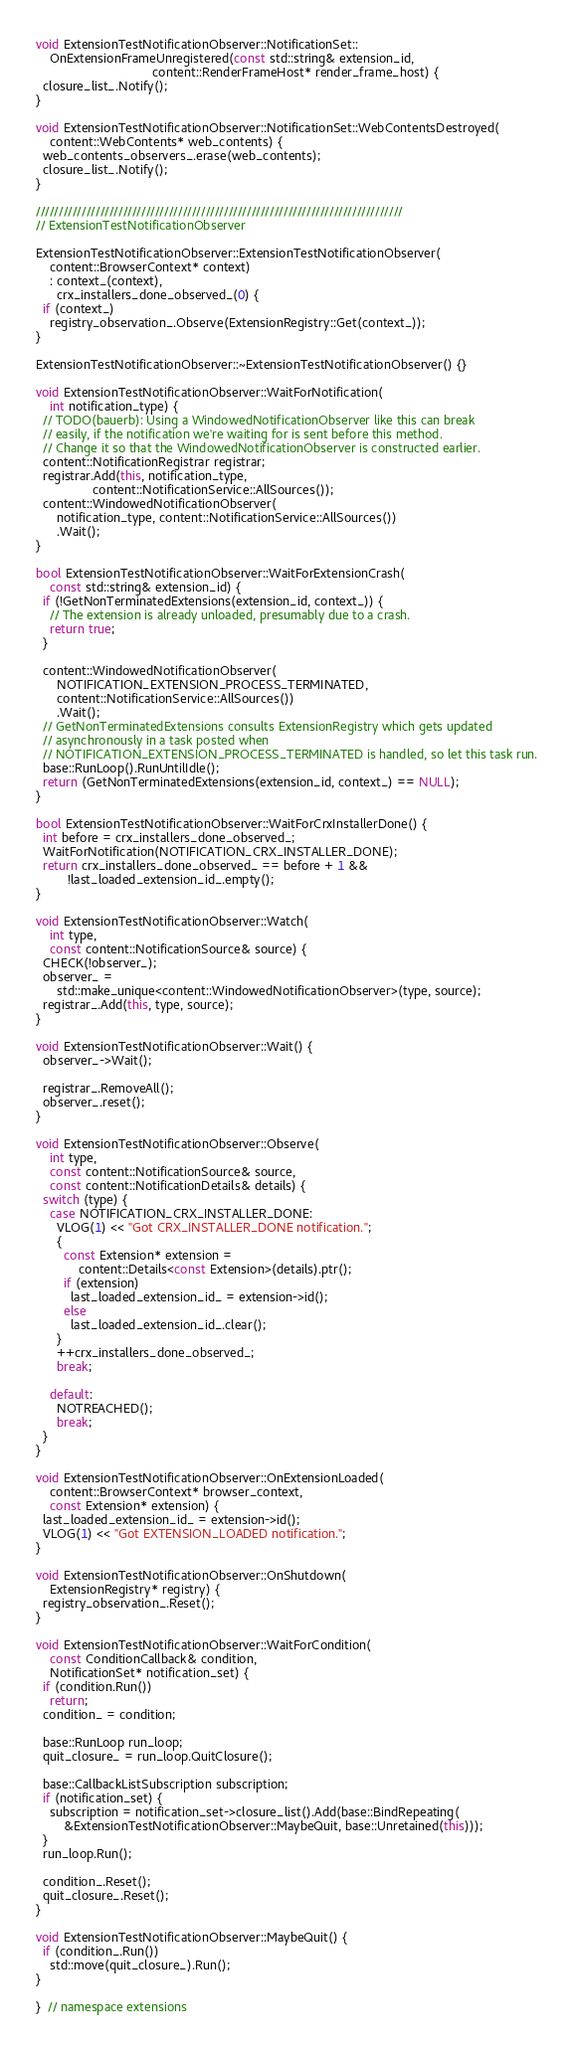<code> <loc_0><loc_0><loc_500><loc_500><_C++_>void ExtensionTestNotificationObserver::NotificationSet::
    OnExtensionFrameUnregistered(const std::string& extension_id,
                                 content::RenderFrameHost* render_frame_host) {
  closure_list_.Notify();
}

void ExtensionTestNotificationObserver::NotificationSet::WebContentsDestroyed(
    content::WebContents* web_contents) {
  web_contents_observers_.erase(web_contents);
  closure_list_.Notify();
}

////////////////////////////////////////////////////////////////////////////////
// ExtensionTestNotificationObserver

ExtensionTestNotificationObserver::ExtensionTestNotificationObserver(
    content::BrowserContext* context)
    : context_(context),
      crx_installers_done_observed_(0) {
  if (context_)
    registry_observation_.Observe(ExtensionRegistry::Get(context_));
}

ExtensionTestNotificationObserver::~ExtensionTestNotificationObserver() {}

void ExtensionTestNotificationObserver::WaitForNotification(
    int notification_type) {
  // TODO(bauerb): Using a WindowedNotificationObserver like this can break
  // easily, if the notification we're waiting for is sent before this method.
  // Change it so that the WindowedNotificationObserver is constructed earlier.
  content::NotificationRegistrar registrar;
  registrar.Add(this, notification_type,
                content::NotificationService::AllSources());
  content::WindowedNotificationObserver(
      notification_type, content::NotificationService::AllSources())
      .Wait();
}

bool ExtensionTestNotificationObserver::WaitForExtensionCrash(
    const std::string& extension_id) {
  if (!GetNonTerminatedExtensions(extension_id, context_)) {
    // The extension is already unloaded, presumably due to a crash.
    return true;
  }

  content::WindowedNotificationObserver(
      NOTIFICATION_EXTENSION_PROCESS_TERMINATED,
      content::NotificationService::AllSources())
      .Wait();
  // GetNonTerminatedExtensions consults ExtensionRegistry which gets updated
  // asynchronously in a task posted when
  // NOTIFICATION_EXTENSION_PROCESS_TERMINATED is handled, so let this task run.
  base::RunLoop().RunUntilIdle();
  return (GetNonTerminatedExtensions(extension_id, context_) == NULL);
}

bool ExtensionTestNotificationObserver::WaitForCrxInstallerDone() {
  int before = crx_installers_done_observed_;
  WaitForNotification(NOTIFICATION_CRX_INSTALLER_DONE);
  return crx_installers_done_observed_ == before + 1 &&
         !last_loaded_extension_id_.empty();
}

void ExtensionTestNotificationObserver::Watch(
    int type,
    const content::NotificationSource& source) {
  CHECK(!observer_);
  observer_ =
      std::make_unique<content::WindowedNotificationObserver>(type, source);
  registrar_.Add(this, type, source);
}

void ExtensionTestNotificationObserver::Wait() {
  observer_->Wait();

  registrar_.RemoveAll();
  observer_.reset();
}

void ExtensionTestNotificationObserver::Observe(
    int type,
    const content::NotificationSource& source,
    const content::NotificationDetails& details) {
  switch (type) {
    case NOTIFICATION_CRX_INSTALLER_DONE:
      VLOG(1) << "Got CRX_INSTALLER_DONE notification.";
      {
        const Extension* extension =
            content::Details<const Extension>(details).ptr();
        if (extension)
          last_loaded_extension_id_ = extension->id();
        else
          last_loaded_extension_id_.clear();
      }
      ++crx_installers_done_observed_;
      break;

    default:
      NOTREACHED();
      break;
  }
}

void ExtensionTestNotificationObserver::OnExtensionLoaded(
    content::BrowserContext* browser_context,
    const Extension* extension) {
  last_loaded_extension_id_ = extension->id();
  VLOG(1) << "Got EXTENSION_LOADED notification.";
}

void ExtensionTestNotificationObserver::OnShutdown(
    ExtensionRegistry* registry) {
  registry_observation_.Reset();
}

void ExtensionTestNotificationObserver::WaitForCondition(
    const ConditionCallback& condition,
    NotificationSet* notification_set) {
  if (condition.Run())
    return;
  condition_ = condition;

  base::RunLoop run_loop;
  quit_closure_ = run_loop.QuitClosure();

  base::CallbackListSubscription subscription;
  if (notification_set) {
    subscription = notification_set->closure_list().Add(base::BindRepeating(
        &ExtensionTestNotificationObserver::MaybeQuit, base::Unretained(this)));
  }
  run_loop.Run();

  condition_.Reset();
  quit_closure_.Reset();
}

void ExtensionTestNotificationObserver::MaybeQuit() {
  if (condition_.Run())
    std::move(quit_closure_).Run();
}

}  // namespace extensions
</code> 